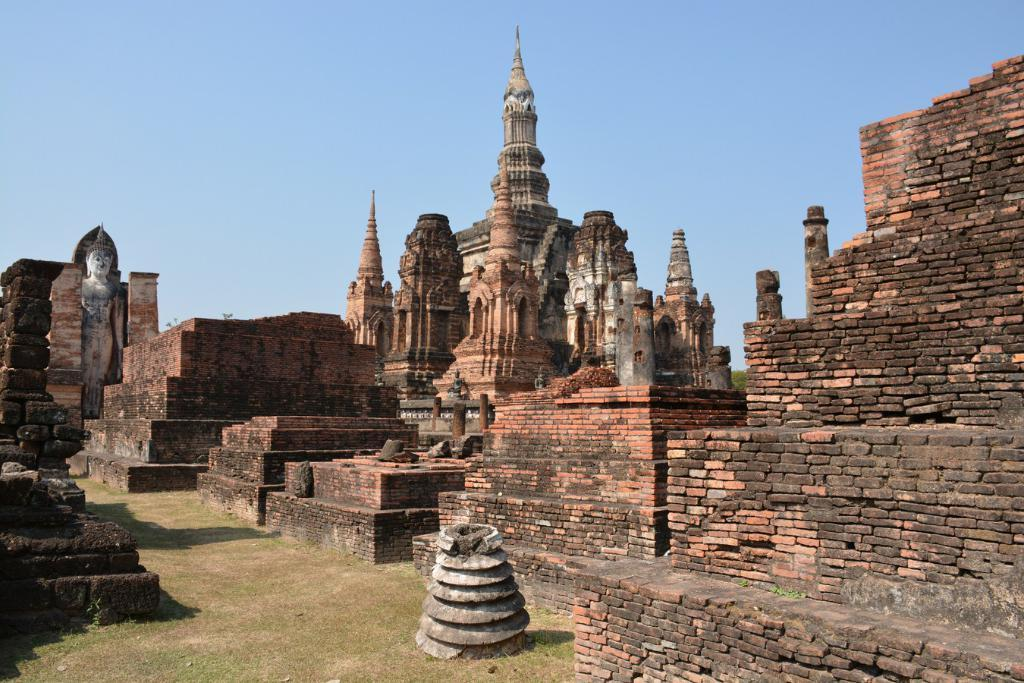What type of structure is depicted in the image? The structure resembles a temple. What materials are used to build the structure? The image consists of walls and bricks. What is visible at the bottom of the image? There is green grass at the bottom of the image. What is visible at the top of the image? The sky is visible at the top of the image. What type of history can be learned from the ring found in the oatmeal in the image? There is no ring or oatmeal present in the image, so no such history can be learned. 